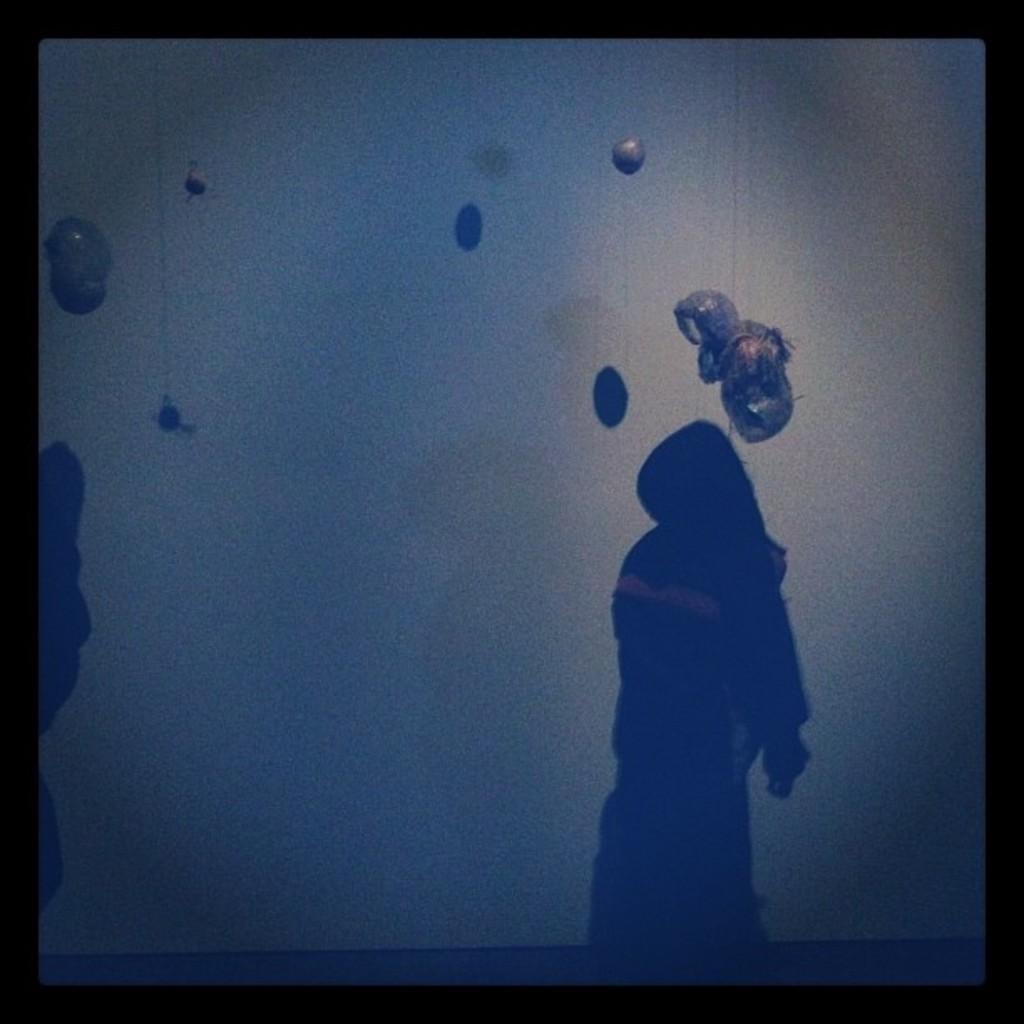How would you describe the overall lighting in the image? The image is dark. What can be seen in the image due to the presence of light and shadow? There is a shadow of a person in the image. What is unusual about the objects in the image? There are objects in the air in the image. What color is the border of the image? The boundaries of the image are black in color. How many chairs are being exchanged in the image? There are no chairs present in the image, nor is there any exchange taking place. 